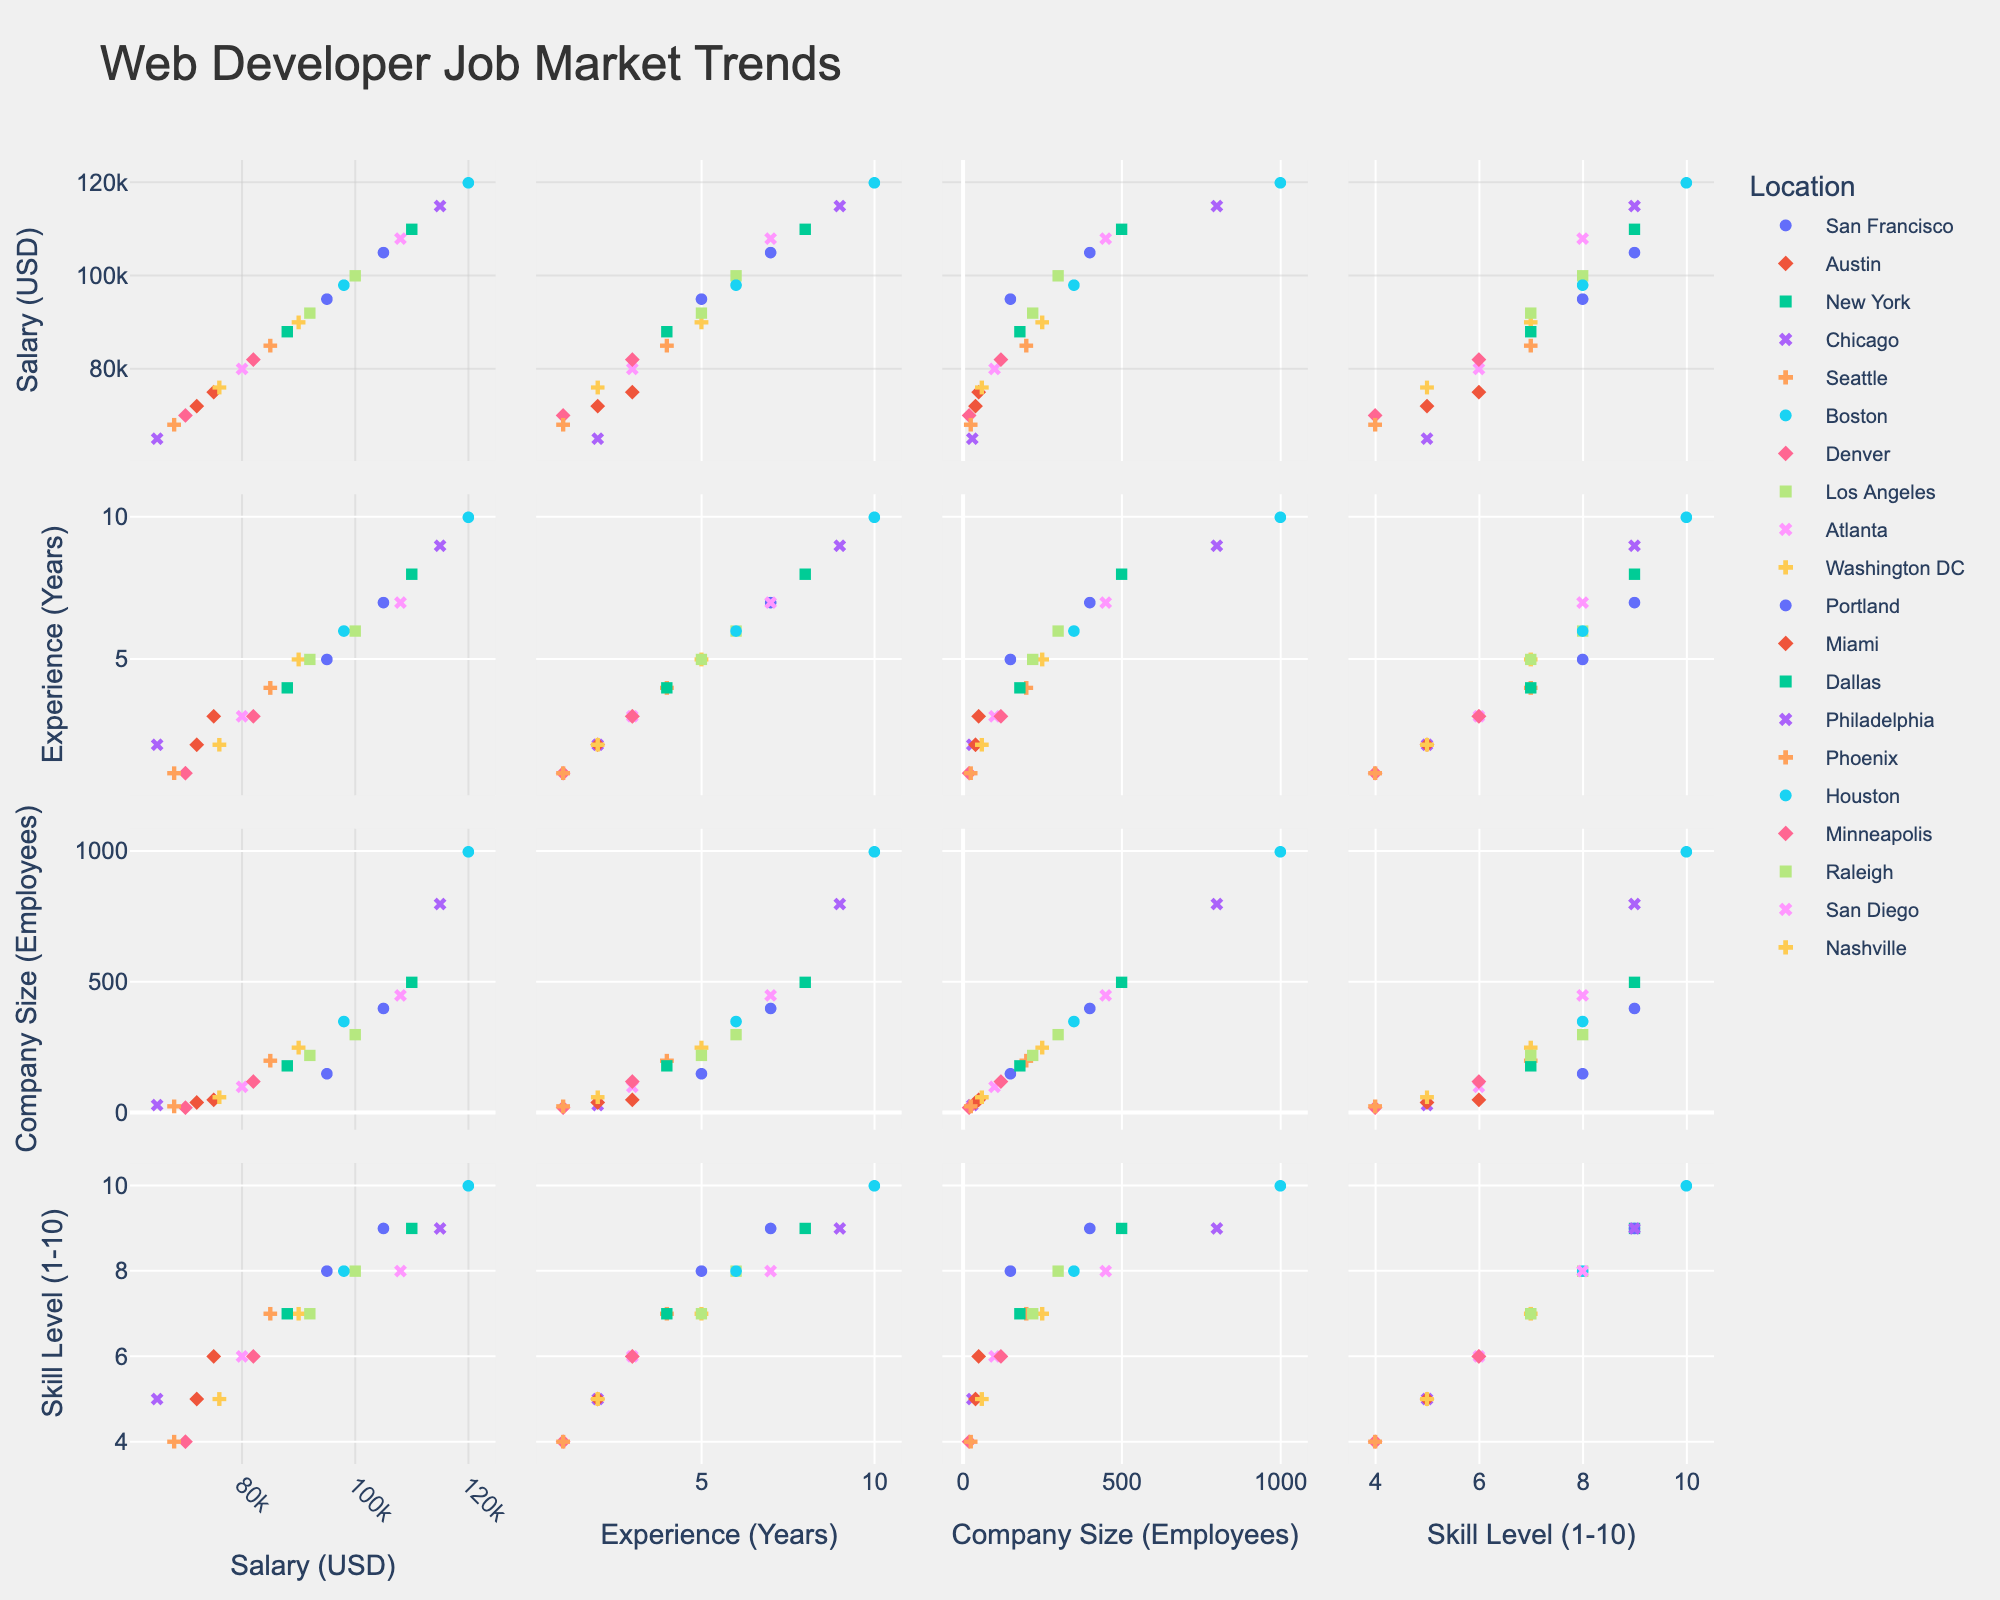What is the title of the scatterplot matrix? The title is often displayed at the top of the scatterplot matrix. It gives an overview of what the visual representation is about.
Answer: Web Developer Job Market Trends How many dimensions are visualized in the scatterplot matrix? Count the number of different metrics used on the axes. Each metric represents a dimension.
Answer: 4 Which location has the highest salary data point? Identify the cluster of points colored similarly and look for the highest value on the Salary axis among that cluster.
Answer: Boston What is the general trend between Salary and Skill Level? Observe the scatterplots where Salary and Skill Level are on the axes, and look for patterns such as upward or downward trends.
Answer: Positive correlation Which data points have the least experience but a high salary? Focus on the intersection between low values on the Experience axis and high values on the Salary axis.
Answer: Denver (1 year, 70000 USD) Does San Francisco generally show higher salaries compared to other locations? Examine the cluster of points for San Francisco and compare their placement on the Salary axis with clusters of other locations.
Answer: Yes What can you say about the salary distribution for web developers in New York compared to San Francisco? Compare the range and spread of the salary data points for New York and San Francisco along the Salary axis.
Answer: New York covers a higher range How does company size relate to skill level in the data? Look at the scatterplots intersecting Skill Level and Company Size axes to identify any observable relationships or trends.
Answer: Positive correlation Which location has the largest company size data point? Find the highest value along the Company Size axis and observe the corresponding location.
Answer: Boston Are there any locations that show a weak correlation between experience and skill level? Check scatterplots where both axes are Experience and Skill Level, and look for patterns or lack thereof for different locations.
Answer: Multiple locations show varied patterns, such as Austin and Phoenix 